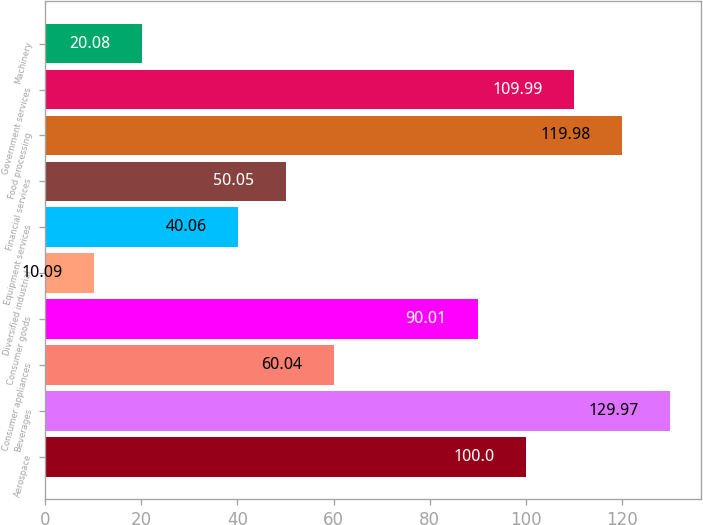Convert chart to OTSL. <chart><loc_0><loc_0><loc_500><loc_500><bar_chart><fcel>Aerospace<fcel>Beverages<fcel>Consumer appliances<fcel>Consumer goods<fcel>Diversified industrial<fcel>Equipment services<fcel>Financial services<fcel>Food processing<fcel>Government services<fcel>Machinery<nl><fcel>100<fcel>129.97<fcel>60.04<fcel>90.01<fcel>10.09<fcel>40.06<fcel>50.05<fcel>119.98<fcel>109.99<fcel>20.08<nl></chart> 